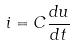Convert formula to latex. <formula><loc_0><loc_0><loc_500><loc_500>i = C \frac { d u } { d t }</formula> 